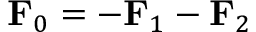Convert formula to latex. <formula><loc_0><loc_0><loc_500><loc_500>F _ { 0 } = - F _ { 1 } - F _ { 2 }</formula> 